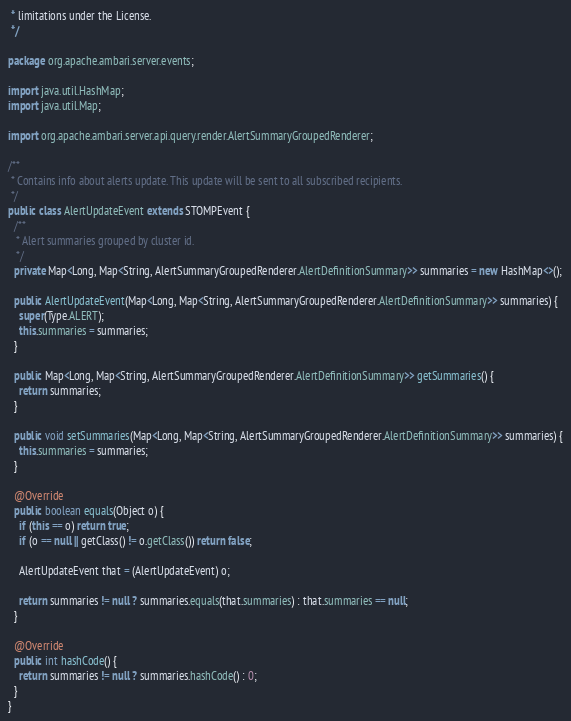Convert code to text. <code><loc_0><loc_0><loc_500><loc_500><_Java_> * limitations under the License.
 */

package org.apache.ambari.server.events;

import java.util.HashMap;
import java.util.Map;

import org.apache.ambari.server.api.query.render.AlertSummaryGroupedRenderer;

/**
 * Contains info about alerts update. This update will be sent to all subscribed recipients.
 */
public class AlertUpdateEvent extends STOMPEvent {
  /**
   * Alert summaries grouped by cluster id.
   */
  private Map<Long, Map<String, AlertSummaryGroupedRenderer.AlertDefinitionSummary>> summaries = new HashMap<>();

  public AlertUpdateEvent(Map<Long, Map<String, AlertSummaryGroupedRenderer.AlertDefinitionSummary>> summaries) {
    super(Type.ALERT);
    this.summaries = summaries;
  }

  public Map<Long, Map<String, AlertSummaryGroupedRenderer.AlertDefinitionSummary>> getSummaries() {
    return summaries;
  }

  public void setSummaries(Map<Long, Map<String, AlertSummaryGroupedRenderer.AlertDefinitionSummary>> summaries) {
    this.summaries = summaries;
  }

  @Override
  public boolean equals(Object o) {
    if (this == o) return true;
    if (o == null || getClass() != o.getClass()) return false;

    AlertUpdateEvent that = (AlertUpdateEvent) o;

    return summaries != null ? summaries.equals(that.summaries) : that.summaries == null;
  }

  @Override
  public int hashCode() {
    return summaries != null ? summaries.hashCode() : 0;
  }
}
</code> 